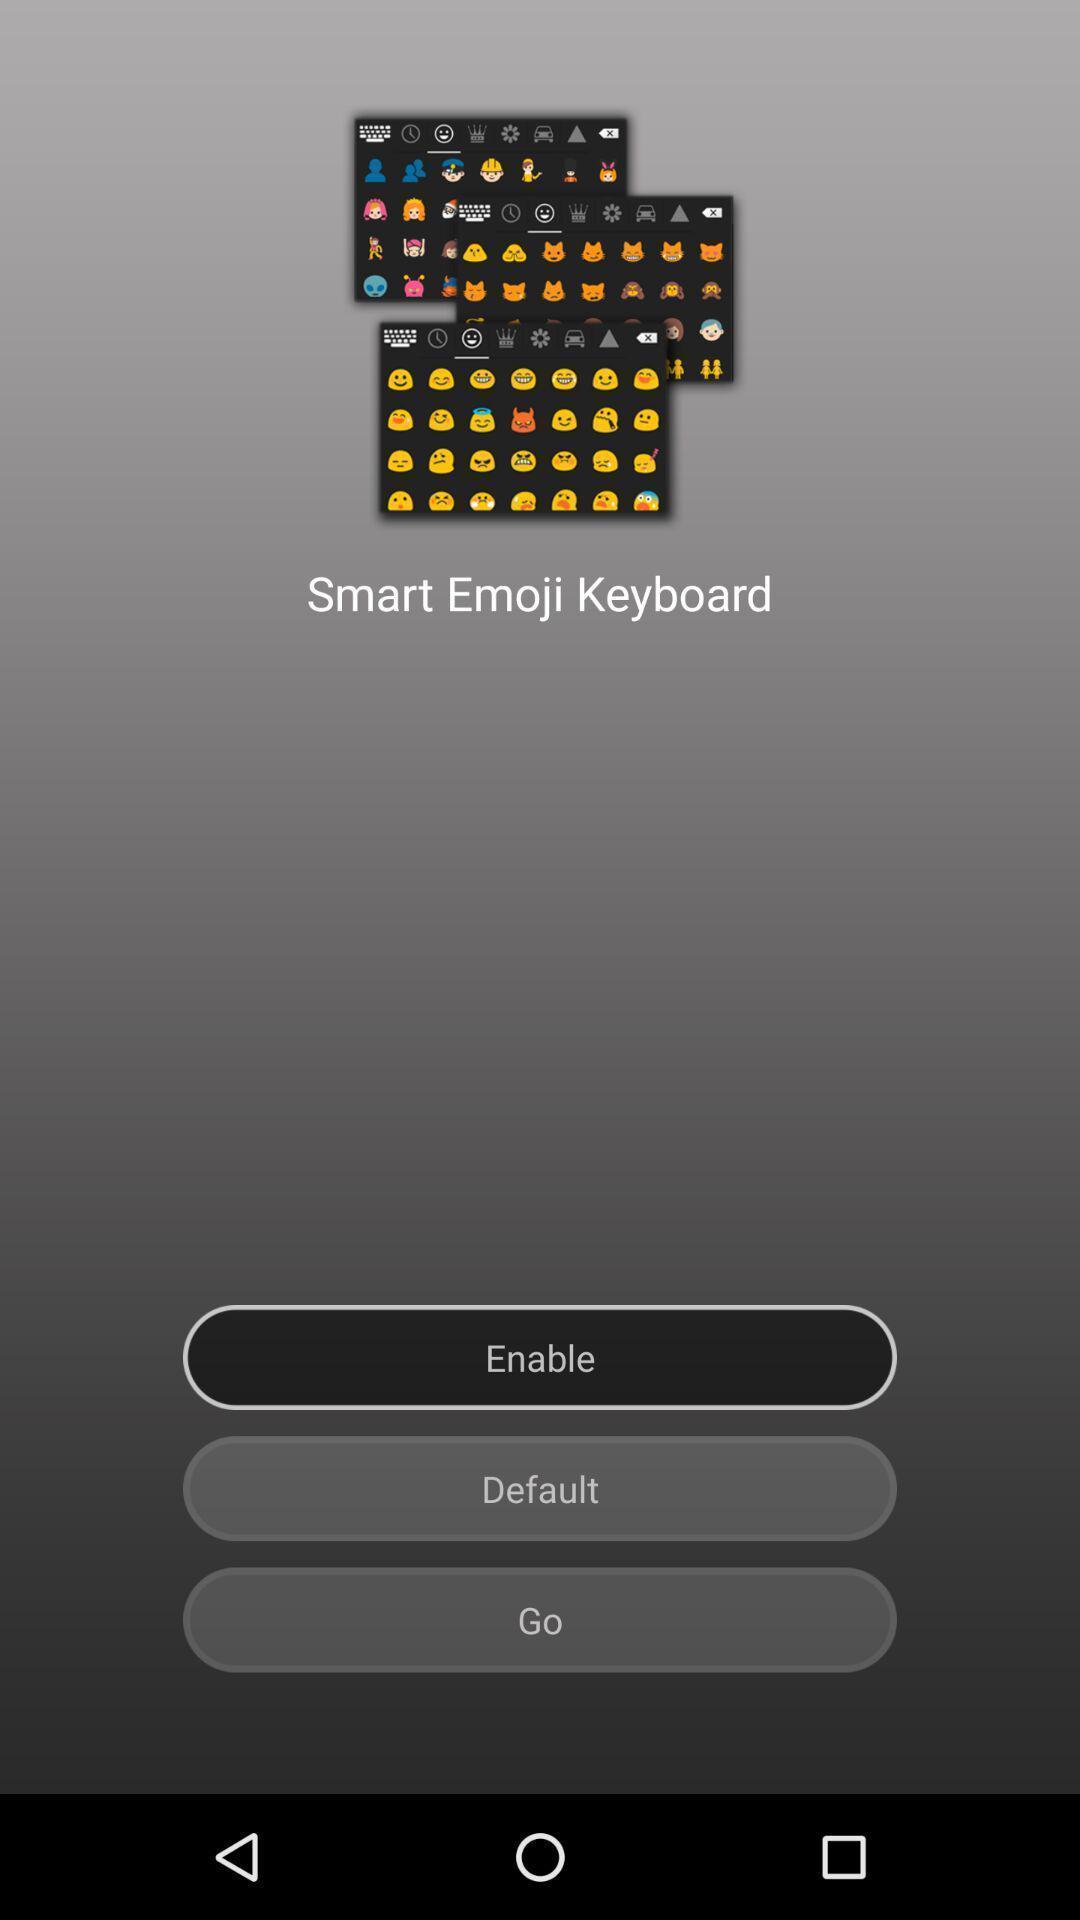What is the overall content of this screenshot? Page displaying to enable to smart emoji keyboard. 